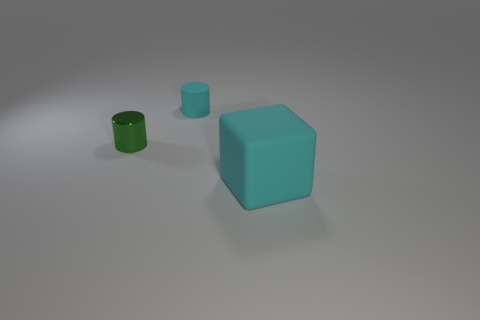Is there anything else that is made of the same material as the small green object?
Provide a short and direct response. No. Is there any other thing that is the same size as the cyan rubber cube?
Provide a short and direct response. No. Are there any other things that have the same shape as the large cyan matte object?
Your answer should be very brief. No. There is a cyan thing that is behind the cyan thing that is on the right side of the cyan matte cylinder; what is it made of?
Keep it short and to the point. Rubber. There is a rubber object that is to the left of the cyan block; how big is it?
Make the answer very short. Small. What color is the object that is to the right of the green cylinder and left of the cube?
Your answer should be compact. Cyan. There is a cyan cylinder that is on the left side of the block; does it have the same size as the big cyan matte cube?
Give a very brief answer. No. Are there any small green cylinders to the right of the rubber object behind the green cylinder?
Your answer should be compact. No. What is the material of the tiny green cylinder?
Ensure brevity in your answer.  Metal. Are there any rubber cubes behind the tiny metallic cylinder?
Offer a terse response. No. 